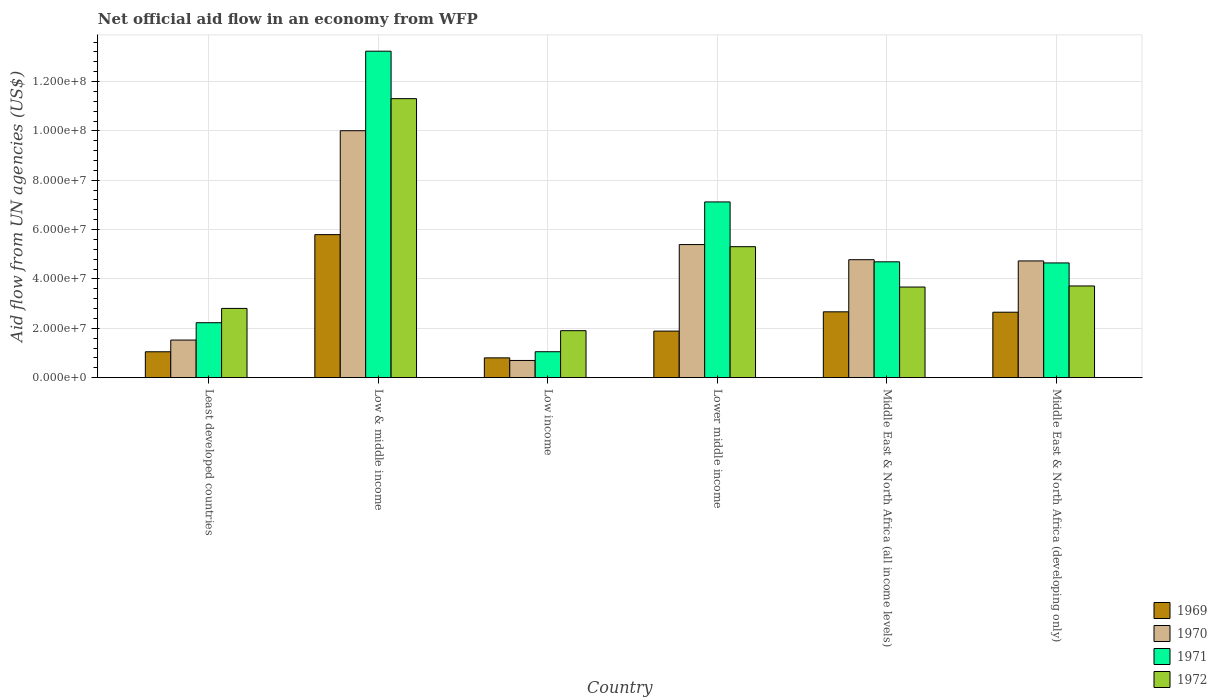How many different coloured bars are there?
Make the answer very short. 4. Are the number of bars on each tick of the X-axis equal?
Your answer should be very brief. Yes. How many bars are there on the 6th tick from the left?
Offer a very short reply. 4. What is the label of the 5th group of bars from the left?
Keep it short and to the point. Middle East & North Africa (all income levels). What is the net official aid flow in 1970 in Least developed countries?
Ensure brevity in your answer.  1.52e+07. Across all countries, what is the maximum net official aid flow in 1970?
Ensure brevity in your answer.  1.00e+08. Across all countries, what is the minimum net official aid flow in 1972?
Provide a short and direct response. 1.90e+07. In which country was the net official aid flow in 1970 maximum?
Offer a terse response. Low & middle income. In which country was the net official aid flow in 1971 minimum?
Your answer should be very brief. Low income. What is the total net official aid flow in 1972 in the graph?
Offer a very short reply. 2.87e+08. What is the difference between the net official aid flow in 1971 in Low income and that in Lower middle income?
Provide a succinct answer. -6.07e+07. What is the difference between the net official aid flow in 1972 in Low & middle income and the net official aid flow in 1971 in Least developed countries?
Offer a very short reply. 9.08e+07. What is the average net official aid flow in 1972 per country?
Offer a very short reply. 4.79e+07. What is the difference between the net official aid flow of/in 1972 and net official aid flow of/in 1970 in Middle East & North Africa (all income levels)?
Give a very brief answer. -1.11e+07. In how many countries, is the net official aid flow in 1971 greater than 60000000 US$?
Your answer should be compact. 2. What is the ratio of the net official aid flow in 1972 in Middle East & North Africa (all income levels) to that in Middle East & North Africa (developing only)?
Ensure brevity in your answer.  0.99. Is the net official aid flow in 1972 in Low & middle income less than that in Middle East & North Africa (all income levels)?
Your answer should be very brief. No. Is the difference between the net official aid flow in 1972 in Low & middle income and Lower middle income greater than the difference between the net official aid flow in 1970 in Low & middle income and Lower middle income?
Offer a very short reply. Yes. What is the difference between the highest and the second highest net official aid flow in 1972?
Make the answer very short. 7.59e+07. What is the difference between the highest and the lowest net official aid flow in 1972?
Offer a terse response. 9.40e+07. Is it the case that in every country, the sum of the net official aid flow in 1971 and net official aid flow in 1969 is greater than the sum of net official aid flow in 1972 and net official aid flow in 1970?
Make the answer very short. No. What does the 1st bar from the left in Lower middle income represents?
Keep it short and to the point. 1969. Is it the case that in every country, the sum of the net official aid flow in 1971 and net official aid flow in 1969 is greater than the net official aid flow in 1970?
Your answer should be compact. Yes. Are all the bars in the graph horizontal?
Keep it short and to the point. No. How many countries are there in the graph?
Keep it short and to the point. 6. What is the difference between two consecutive major ticks on the Y-axis?
Your response must be concise. 2.00e+07. Are the values on the major ticks of Y-axis written in scientific E-notation?
Your answer should be very brief. Yes. Does the graph contain any zero values?
Your response must be concise. No. How many legend labels are there?
Your response must be concise. 4. How are the legend labels stacked?
Offer a terse response. Vertical. What is the title of the graph?
Make the answer very short. Net official aid flow in an economy from WFP. Does "2006" appear as one of the legend labels in the graph?
Your response must be concise. No. What is the label or title of the X-axis?
Provide a succinct answer. Country. What is the label or title of the Y-axis?
Your answer should be very brief. Aid flow from UN agencies (US$). What is the Aid flow from UN agencies (US$) of 1969 in Least developed countries?
Provide a short and direct response. 1.05e+07. What is the Aid flow from UN agencies (US$) of 1970 in Least developed countries?
Your response must be concise. 1.52e+07. What is the Aid flow from UN agencies (US$) of 1971 in Least developed countries?
Keep it short and to the point. 2.23e+07. What is the Aid flow from UN agencies (US$) in 1972 in Least developed countries?
Make the answer very short. 2.81e+07. What is the Aid flow from UN agencies (US$) of 1969 in Low & middle income?
Your answer should be very brief. 5.80e+07. What is the Aid flow from UN agencies (US$) of 1970 in Low & middle income?
Your answer should be compact. 1.00e+08. What is the Aid flow from UN agencies (US$) of 1971 in Low & middle income?
Make the answer very short. 1.32e+08. What is the Aid flow from UN agencies (US$) in 1972 in Low & middle income?
Offer a very short reply. 1.13e+08. What is the Aid flow from UN agencies (US$) in 1969 in Low income?
Offer a terse response. 8.02e+06. What is the Aid flow from UN agencies (US$) of 1970 in Low income?
Ensure brevity in your answer.  6.97e+06. What is the Aid flow from UN agencies (US$) in 1971 in Low income?
Your response must be concise. 1.05e+07. What is the Aid flow from UN agencies (US$) in 1972 in Low income?
Your response must be concise. 1.90e+07. What is the Aid flow from UN agencies (US$) of 1969 in Lower middle income?
Your answer should be compact. 1.89e+07. What is the Aid flow from UN agencies (US$) in 1970 in Lower middle income?
Ensure brevity in your answer.  5.39e+07. What is the Aid flow from UN agencies (US$) of 1971 in Lower middle income?
Keep it short and to the point. 7.12e+07. What is the Aid flow from UN agencies (US$) in 1972 in Lower middle income?
Make the answer very short. 5.31e+07. What is the Aid flow from UN agencies (US$) in 1969 in Middle East & North Africa (all income levels)?
Your response must be concise. 2.67e+07. What is the Aid flow from UN agencies (US$) in 1970 in Middle East & North Africa (all income levels)?
Offer a very short reply. 4.78e+07. What is the Aid flow from UN agencies (US$) in 1971 in Middle East & North Africa (all income levels)?
Give a very brief answer. 4.69e+07. What is the Aid flow from UN agencies (US$) in 1972 in Middle East & North Africa (all income levels)?
Offer a terse response. 3.67e+07. What is the Aid flow from UN agencies (US$) of 1969 in Middle East & North Africa (developing only)?
Provide a succinct answer. 2.65e+07. What is the Aid flow from UN agencies (US$) of 1970 in Middle East & North Africa (developing only)?
Offer a terse response. 4.73e+07. What is the Aid flow from UN agencies (US$) of 1971 in Middle East & North Africa (developing only)?
Give a very brief answer. 4.65e+07. What is the Aid flow from UN agencies (US$) in 1972 in Middle East & North Africa (developing only)?
Your answer should be very brief. 3.72e+07. Across all countries, what is the maximum Aid flow from UN agencies (US$) in 1969?
Make the answer very short. 5.80e+07. Across all countries, what is the maximum Aid flow from UN agencies (US$) in 1970?
Your response must be concise. 1.00e+08. Across all countries, what is the maximum Aid flow from UN agencies (US$) of 1971?
Your answer should be compact. 1.32e+08. Across all countries, what is the maximum Aid flow from UN agencies (US$) in 1972?
Your response must be concise. 1.13e+08. Across all countries, what is the minimum Aid flow from UN agencies (US$) in 1969?
Provide a short and direct response. 8.02e+06. Across all countries, what is the minimum Aid flow from UN agencies (US$) of 1970?
Offer a terse response. 6.97e+06. Across all countries, what is the minimum Aid flow from UN agencies (US$) of 1971?
Give a very brief answer. 1.05e+07. Across all countries, what is the minimum Aid flow from UN agencies (US$) of 1972?
Offer a terse response. 1.90e+07. What is the total Aid flow from UN agencies (US$) in 1969 in the graph?
Provide a short and direct response. 1.49e+08. What is the total Aid flow from UN agencies (US$) of 1970 in the graph?
Provide a short and direct response. 2.71e+08. What is the total Aid flow from UN agencies (US$) of 1971 in the graph?
Give a very brief answer. 3.30e+08. What is the total Aid flow from UN agencies (US$) in 1972 in the graph?
Your answer should be very brief. 2.87e+08. What is the difference between the Aid flow from UN agencies (US$) of 1969 in Least developed countries and that in Low & middle income?
Offer a very short reply. -4.75e+07. What is the difference between the Aid flow from UN agencies (US$) of 1970 in Least developed countries and that in Low & middle income?
Your answer should be compact. -8.48e+07. What is the difference between the Aid flow from UN agencies (US$) in 1971 in Least developed countries and that in Low & middle income?
Make the answer very short. -1.10e+08. What is the difference between the Aid flow from UN agencies (US$) in 1972 in Least developed countries and that in Low & middle income?
Provide a succinct answer. -8.50e+07. What is the difference between the Aid flow from UN agencies (US$) in 1969 in Least developed countries and that in Low income?
Make the answer very short. 2.47e+06. What is the difference between the Aid flow from UN agencies (US$) of 1970 in Least developed countries and that in Low income?
Make the answer very short. 8.27e+06. What is the difference between the Aid flow from UN agencies (US$) of 1971 in Least developed countries and that in Low income?
Offer a terse response. 1.18e+07. What is the difference between the Aid flow from UN agencies (US$) of 1972 in Least developed countries and that in Low income?
Your response must be concise. 9.02e+06. What is the difference between the Aid flow from UN agencies (US$) in 1969 in Least developed countries and that in Lower middle income?
Offer a terse response. -8.38e+06. What is the difference between the Aid flow from UN agencies (US$) of 1970 in Least developed countries and that in Lower middle income?
Provide a succinct answer. -3.87e+07. What is the difference between the Aid flow from UN agencies (US$) in 1971 in Least developed countries and that in Lower middle income?
Your answer should be very brief. -4.89e+07. What is the difference between the Aid flow from UN agencies (US$) of 1972 in Least developed countries and that in Lower middle income?
Provide a short and direct response. -2.50e+07. What is the difference between the Aid flow from UN agencies (US$) in 1969 in Least developed countries and that in Middle East & North Africa (all income levels)?
Keep it short and to the point. -1.62e+07. What is the difference between the Aid flow from UN agencies (US$) of 1970 in Least developed countries and that in Middle East & North Africa (all income levels)?
Give a very brief answer. -3.26e+07. What is the difference between the Aid flow from UN agencies (US$) in 1971 in Least developed countries and that in Middle East & North Africa (all income levels)?
Your response must be concise. -2.47e+07. What is the difference between the Aid flow from UN agencies (US$) in 1972 in Least developed countries and that in Middle East & North Africa (all income levels)?
Give a very brief answer. -8.66e+06. What is the difference between the Aid flow from UN agencies (US$) of 1969 in Least developed countries and that in Middle East & North Africa (developing only)?
Give a very brief answer. -1.60e+07. What is the difference between the Aid flow from UN agencies (US$) of 1970 in Least developed countries and that in Middle East & North Africa (developing only)?
Give a very brief answer. -3.21e+07. What is the difference between the Aid flow from UN agencies (US$) of 1971 in Least developed countries and that in Middle East & North Africa (developing only)?
Your answer should be very brief. -2.42e+07. What is the difference between the Aid flow from UN agencies (US$) of 1972 in Least developed countries and that in Middle East & North Africa (developing only)?
Offer a very short reply. -9.10e+06. What is the difference between the Aid flow from UN agencies (US$) of 1969 in Low & middle income and that in Low income?
Give a very brief answer. 4.99e+07. What is the difference between the Aid flow from UN agencies (US$) in 1970 in Low & middle income and that in Low income?
Your answer should be compact. 9.31e+07. What is the difference between the Aid flow from UN agencies (US$) of 1971 in Low & middle income and that in Low income?
Your answer should be compact. 1.22e+08. What is the difference between the Aid flow from UN agencies (US$) in 1972 in Low & middle income and that in Low income?
Offer a very short reply. 9.40e+07. What is the difference between the Aid flow from UN agencies (US$) of 1969 in Low & middle income and that in Lower middle income?
Ensure brevity in your answer.  3.91e+07. What is the difference between the Aid flow from UN agencies (US$) of 1970 in Low & middle income and that in Lower middle income?
Your answer should be very brief. 4.61e+07. What is the difference between the Aid flow from UN agencies (US$) of 1971 in Low & middle income and that in Lower middle income?
Provide a succinct answer. 6.11e+07. What is the difference between the Aid flow from UN agencies (US$) in 1972 in Low & middle income and that in Lower middle income?
Offer a terse response. 6.00e+07. What is the difference between the Aid flow from UN agencies (US$) of 1969 in Low & middle income and that in Middle East & North Africa (all income levels)?
Ensure brevity in your answer.  3.13e+07. What is the difference between the Aid flow from UN agencies (US$) in 1970 in Low & middle income and that in Middle East & North Africa (all income levels)?
Make the answer very short. 5.23e+07. What is the difference between the Aid flow from UN agencies (US$) in 1971 in Low & middle income and that in Middle East & North Africa (all income levels)?
Make the answer very short. 8.54e+07. What is the difference between the Aid flow from UN agencies (US$) in 1972 in Low & middle income and that in Middle East & North Africa (all income levels)?
Your answer should be compact. 7.63e+07. What is the difference between the Aid flow from UN agencies (US$) of 1969 in Low & middle income and that in Middle East & North Africa (developing only)?
Keep it short and to the point. 3.14e+07. What is the difference between the Aid flow from UN agencies (US$) in 1970 in Low & middle income and that in Middle East & North Africa (developing only)?
Your answer should be compact. 5.28e+07. What is the difference between the Aid flow from UN agencies (US$) of 1971 in Low & middle income and that in Middle East & North Africa (developing only)?
Provide a short and direct response. 8.58e+07. What is the difference between the Aid flow from UN agencies (US$) in 1972 in Low & middle income and that in Middle East & North Africa (developing only)?
Your answer should be compact. 7.59e+07. What is the difference between the Aid flow from UN agencies (US$) of 1969 in Low income and that in Lower middle income?
Offer a terse response. -1.08e+07. What is the difference between the Aid flow from UN agencies (US$) of 1970 in Low income and that in Lower middle income?
Make the answer very short. -4.70e+07. What is the difference between the Aid flow from UN agencies (US$) in 1971 in Low income and that in Lower middle income?
Your answer should be very brief. -6.07e+07. What is the difference between the Aid flow from UN agencies (US$) in 1972 in Low income and that in Lower middle income?
Your answer should be very brief. -3.40e+07. What is the difference between the Aid flow from UN agencies (US$) in 1969 in Low income and that in Middle East & North Africa (all income levels)?
Your response must be concise. -1.87e+07. What is the difference between the Aid flow from UN agencies (US$) in 1970 in Low income and that in Middle East & North Africa (all income levels)?
Your response must be concise. -4.08e+07. What is the difference between the Aid flow from UN agencies (US$) in 1971 in Low income and that in Middle East & North Africa (all income levels)?
Provide a succinct answer. -3.64e+07. What is the difference between the Aid flow from UN agencies (US$) of 1972 in Low income and that in Middle East & North Africa (all income levels)?
Keep it short and to the point. -1.77e+07. What is the difference between the Aid flow from UN agencies (US$) in 1969 in Low income and that in Middle East & North Africa (developing only)?
Provide a short and direct response. -1.85e+07. What is the difference between the Aid flow from UN agencies (US$) in 1970 in Low income and that in Middle East & North Africa (developing only)?
Ensure brevity in your answer.  -4.03e+07. What is the difference between the Aid flow from UN agencies (US$) in 1971 in Low income and that in Middle East & North Africa (developing only)?
Offer a terse response. -3.60e+07. What is the difference between the Aid flow from UN agencies (US$) in 1972 in Low income and that in Middle East & North Africa (developing only)?
Ensure brevity in your answer.  -1.81e+07. What is the difference between the Aid flow from UN agencies (US$) of 1969 in Lower middle income and that in Middle East & North Africa (all income levels)?
Your answer should be very brief. -7.81e+06. What is the difference between the Aid flow from UN agencies (US$) of 1970 in Lower middle income and that in Middle East & North Africa (all income levels)?
Your answer should be compact. 6.13e+06. What is the difference between the Aid flow from UN agencies (US$) of 1971 in Lower middle income and that in Middle East & North Africa (all income levels)?
Keep it short and to the point. 2.43e+07. What is the difference between the Aid flow from UN agencies (US$) in 1972 in Lower middle income and that in Middle East & North Africa (all income levels)?
Provide a succinct answer. 1.64e+07. What is the difference between the Aid flow from UN agencies (US$) of 1969 in Lower middle income and that in Middle East & North Africa (developing only)?
Your answer should be compact. -7.65e+06. What is the difference between the Aid flow from UN agencies (US$) in 1970 in Lower middle income and that in Middle East & North Africa (developing only)?
Keep it short and to the point. 6.63e+06. What is the difference between the Aid flow from UN agencies (US$) of 1971 in Lower middle income and that in Middle East & North Africa (developing only)?
Ensure brevity in your answer.  2.47e+07. What is the difference between the Aid flow from UN agencies (US$) of 1972 in Lower middle income and that in Middle East & North Africa (developing only)?
Provide a succinct answer. 1.59e+07. What is the difference between the Aid flow from UN agencies (US$) of 1972 in Middle East & North Africa (all income levels) and that in Middle East & North Africa (developing only)?
Your answer should be very brief. -4.40e+05. What is the difference between the Aid flow from UN agencies (US$) in 1969 in Least developed countries and the Aid flow from UN agencies (US$) in 1970 in Low & middle income?
Ensure brevity in your answer.  -8.96e+07. What is the difference between the Aid flow from UN agencies (US$) in 1969 in Least developed countries and the Aid flow from UN agencies (US$) in 1971 in Low & middle income?
Your answer should be compact. -1.22e+08. What is the difference between the Aid flow from UN agencies (US$) in 1969 in Least developed countries and the Aid flow from UN agencies (US$) in 1972 in Low & middle income?
Give a very brief answer. -1.03e+08. What is the difference between the Aid flow from UN agencies (US$) in 1970 in Least developed countries and the Aid flow from UN agencies (US$) in 1971 in Low & middle income?
Offer a terse response. -1.17e+08. What is the difference between the Aid flow from UN agencies (US$) of 1970 in Least developed countries and the Aid flow from UN agencies (US$) of 1972 in Low & middle income?
Give a very brief answer. -9.78e+07. What is the difference between the Aid flow from UN agencies (US$) in 1971 in Least developed countries and the Aid flow from UN agencies (US$) in 1972 in Low & middle income?
Offer a terse response. -9.08e+07. What is the difference between the Aid flow from UN agencies (US$) in 1969 in Least developed countries and the Aid flow from UN agencies (US$) in 1970 in Low income?
Make the answer very short. 3.52e+06. What is the difference between the Aid flow from UN agencies (US$) of 1969 in Least developed countries and the Aid flow from UN agencies (US$) of 1972 in Low income?
Your response must be concise. -8.55e+06. What is the difference between the Aid flow from UN agencies (US$) in 1970 in Least developed countries and the Aid flow from UN agencies (US$) in 1971 in Low income?
Offer a very short reply. 4.73e+06. What is the difference between the Aid flow from UN agencies (US$) in 1970 in Least developed countries and the Aid flow from UN agencies (US$) in 1972 in Low income?
Make the answer very short. -3.80e+06. What is the difference between the Aid flow from UN agencies (US$) of 1971 in Least developed countries and the Aid flow from UN agencies (US$) of 1972 in Low income?
Your answer should be very brief. 3.23e+06. What is the difference between the Aid flow from UN agencies (US$) in 1969 in Least developed countries and the Aid flow from UN agencies (US$) in 1970 in Lower middle income?
Provide a short and direct response. -4.34e+07. What is the difference between the Aid flow from UN agencies (US$) of 1969 in Least developed countries and the Aid flow from UN agencies (US$) of 1971 in Lower middle income?
Offer a terse response. -6.07e+07. What is the difference between the Aid flow from UN agencies (US$) of 1969 in Least developed countries and the Aid flow from UN agencies (US$) of 1972 in Lower middle income?
Provide a succinct answer. -4.26e+07. What is the difference between the Aid flow from UN agencies (US$) in 1970 in Least developed countries and the Aid flow from UN agencies (US$) in 1971 in Lower middle income?
Your response must be concise. -5.60e+07. What is the difference between the Aid flow from UN agencies (US$) in 1970 in Least developed countries and the Aid flow from UN agencies (US$) in 1972 in Lower middle income?
Keep it short and to the point. -3.78e+07. What is the difference between the Aid flow from UN agencies (US$) in 1971 in Least developed countries and the Aid flow from UN agencies (US$) in 1972 in Lower middle income?
Your response must be concise. -3.08e+07. What is the difference between the Aid flow from UN agencies (US$) of 1969 in Least developed countries and the Aid flow from UN agencies (US$) of 1970 in Middle East & North Africa (all income levels)?
Keep it short and to the point. -3.73e+07. What is the difference between the Aid flow from UN agencies (US$) of 1969 in Least developed countries and the Aid flow from UN agencies (US$) of 1971 in Middle East & North Africa (all income levels)?
Make the answer very short. -3.64e+07. What is the difference between the Aid flow from UN agencies (US$) in 1969 in Least developed countries and the Aid flow from UN agencies (US$) in 1972 in Middle East & North Africa (all income levels)?
Your answer should be very brief. -2.62e+07. What is the difference between the Aid flow from UN agencies (US$) in 1970 in Least developed countries and the Aid flow from UN agencies (US$) in 1971 in Middle East & North Africa (all income levels)?
Offer a terse response. -3.17e+07. What is the difference between the Aid flow from UN agencies (US$) in 1970 in Least developed countries and the Aid flow from UN agencies (US$) in 1972 in Middle East & North Africa (all income levels)?
Give a very brief answer. -2.15e+07. What is the difference between the Aid flow from UN agencies (US$) in 1971 in Least developed countries and the Aid flow from UN agencies (US$) in 1972 in Middle East & North Africa (all income levels)?
Your response must be concise. -1.44e+07. What is the difference between the Aid flow from UN agencies (US$) in 1969 in Least developed countries and the Aid flow from UN agencies (US$) in 1970 in Middle East & North Africa (developing only)?
Offer a terse response. -3.68e+07. What is the difference between the Aid flow from UN agencies (US$) in 1969 in Least developed countries and the Aid flow from UN agencies (US$) in 1971 in Middle East & North Africa (developing only)?
Offer a very short reply. -3.60e+07. What is the difference between the Aid flow from UN agencies (US$) of 1969 in Least developed countries and the Aid flow from UN agencies (US$) of 1972 in Middle East & North Africa (developing only)?
Offer a very short reply. -2.67e+07. What is the difference between the Aid flow from UN agencies (US$) of 1970 in Least developed countries and the Aid flow from UN agencies (US$) of 1971 in Middle East & North Africa (developing only)?
Keep it short and to the point. -3.12e+07. What is the difference between the Aid flow from UN agencies (US$) of 1970 in Least developed countries and the Aid flow from UN agencies (US$) of 1972 in Middle East & North Africa (developing only)?
Offer a terse response. -2.19e+07. What is the difference between the Aid flow from UN agencies (US$) of 1971 in Least developed countries and the Aid flow from UN agencies (US$) of 1972 in Middle East & North Africa (developing only)?
Provide a short and direct response. -1.49e+07. What is the difference between the Aid flow from UN agencies (US$) in 1969 in Low & middle income and the Aid flow from UN agencies (US$) in 1970 in Low income?
Provide a succinct answer. 5.10e+07. What is the difference between the Aid flow from UN agencies (US$) of 1969 in Low & middle income and the Aid flow from UN agencies (US$) of 1971 in Low income?
Provide a short and direct response. 4.74e+07. What is the difference between the Aid flow from UN agencies (US$) of 1969 in Low & middle income and the Aid flow from UN agencies (US$) of 1972 in Low income?
Offer a terse response. 3.89e+07. What is the difference between the Aid flow from UN agencies (US$) in 1970 in Low & middle income and the Aid flow from UN agencies (US$) in 1971 in Low income?
Your response must be concise. 8.96e+07. What is the difference between the Aid flow from UN agencies (US$) of 1970 in Low & middle income and the Aid flow from UN agencies (US$) of 1972 in Low income?
Provide a short and direct response. 8.10e+07. What is the difference between the Aid flow from UN agencies (US$) of 1971 in Low & middle income and the Aid flow from UN agencies (US$) of 1972 in Low income?
Offer a terse response. 1.13e+08. What is the difference between the Aid flow from UN agencies (US$) of 1969 in Low & middle income and the Aid flow from UN agencies (US$) of 1970 in Lower middle income?
Offer a very short reply. 4.03e+06. What is the difference between the Aid flow from UN agencies (US$) in 1969 in Low & middle income and the Aid flow from UN agencies (US$) in 1971 in Lower middle income?
Give a very brief answer. -1.32e+07. What is the difference between the Aid flow from UN agencies (US$) in 1969 in Low & middle income and the Aid flow from UN agencies (US$) in 1972 in Lower middle income?
Offer a very short reply. 4.88e+06. What is the difference between the Aid flow from UN agencies (US$) of 1970 in Low & middle income and the Aid flow from UN agencies (US$) of 1971 in Lower middle income?
Give a very brief answer. 2.89e+07. What is the difference between the Aid flow from UN agencies (US$) in 1970 in Low & middle income and the Aid flow from UN agencies (US$) in 1972 in Lower middle income?
Your answer should be very brief. 4.70e+07. What is the difference between the Aid flow from UN agencies (US$) in 1971 in Low & middle income and the Aid flow from UN agencies (US$) in 1972 in Lower middle income?
Provide a succinct answer. 7.92e+07. What is the difference between the Aid flow from UN agencies (US$) of 1969 in Low & middle income and the Aid flow from UN agencies (US$) of 1970 in Middle East & North Africa (all income levels)?
Offer a very short reply. 1.02e+07. What is the difference between the Aid flow from UN agencies (US$) of 1969 in Low & middle income and the Aid flow from UN agencies (US$) of 1971 in Middle East & North Africa (all income levels)?
Provide a short and direct response. 1.10e+07. What is the difference between the Aid flow from UN agencies (US$) in 1969 in Low & middle income and the Aid flow from UN agencies (US$) in 1972 in Middle East & North Africa (all income levels)?
Offer a very short reply. 2.12e+07. What is the difference between the Aid flow from UN agencies (US$) of 1970 in Low & middle income and the Aid flow from UN agencies (US$) of 1971 in Middle East & North Africa (all income levels)?
Provide a succinct answer. 5.31e+07. What is the difference between the Aid flow from UN agencies (US$) in 1970 in Low & middle income and the Aid flow from UN agencies (US$) in 1972 in Middle East & North Africa (all income levels)?
Your response must be concise. 6.34e+07. What is the difference between the Aid flow from UN agencies (US$) of 1971 in Low & middle income and the Aid flow from UN agencies (US$) of 1972 in Middle East & North Africa (all income levels)?
Ensure brevity in your answer.  9.56e+07. What is the difference between the Aid flow from UN agencies (US$) in 1969 in Low & middle income and the Aid flow from UN agencies (US$) in 1970 in Middle East & North Africa (developing only)?
Make the answer very short. 1.07e+07. What is the difference between the Aid flow from UN agencies (US$) in 1969 in Low & middle income and the Aid flow from UN agencies (US$) in 1971 in Middle East & North Africa (developing only)?
Provide a short and direct response. 1.15e+07. What is the difference between the Aid flow from UN agencies (US$) of 1969 in Low & middle income and the Aid flow from UN agencies (US$) of 1972 in Middle East & North Africa (developing only)?
Offer a very short reply. 2.08e+07. What is the difference between the Aid flow from UN agencies (US$) of 1970 in Low & middle income and the Aid flow from UN agencies (US$) of 1971 in Middle East & North Africa (developing only)?
Offer a terse response. 5.36e+07. What is the difference between the Aid flow from UN agencies (US$) of 1970 in Low & middle income and the Aid flow from UN agencies (US$) of 1972 in Middle East & North Africa (developing only)?
Give a very brief answer. 6.29e+07. What is the difference between the Aid flow from UN agencies (US$) of 1971 in Low & middle income and the Aid flow from UN agencies (US$) of 1972 in Middle East & North Africa (developing only)?
Your answer should be compact. 9.51e+07. What is the difference between the Aid flow from UN agencies (US$) of 1969 in Low income and the Aid flow from UN agencies (US$) of 1970 in Lower middle income?
Offer a terse response. -4.59e+07. What is the difference between the Aid flow from UN agencies (US$) in 1969 in Low income and the Aid flow from UN agencies (US$) in 1971 in Lower middle income?
Ensure brevity in your answer.  -6.32e+07. What is the difference between the Aid flow from UN agencies (US$) in 1969 in Low income and the Aid flow from UN agencies (US$) in 1972 in Lower middle income?
Offer a terse response. -4.51e+07. What is the difference between the Aid flow from UN agencies (US$) of 1970 in Low income and the Aid flow from UN agencies (US$) of 1971 in Lower middle income?
Offer a terse response. -6.42e+07. What is the difference between the Aid flow from UN agencies (US$) in 1970 in Low income and the Aid flow from UN agencies (US$) in 1972 in Lower middle income?
Your answer should be compact. -4.61e+07. What is the difference between the Aid flow from UN agencies (US$) in 1971 in Low income and the Aid flow from UN agencies (US$) in 1972 in Lower middle income?
Make the answer very short. -4.26e+07. What is the difference between the Aid flow from UN agencies (US$) of 1969 in Low income and the Aid flow from UN agencies (US$) of 1970 in Middle East & North Africa (all income levels)?
Offer a very short reply. -3.98e+07. What is the difference between the Aid flow from UN agencies (US$) in 1969 in Low income and the Aid flow from UN agencies (US$) in 1971 in Middle East & North Africa (all income levels)?
Offer a very short reply. -3.89e+07. What is the difference between the Aid flow from UN agencies (US$) of 1969 in Low income and the Aid flow from UN agencies (US$) of 1972 in Middle East & North Africa (all income levels)?
Keep it short and to the point. -2.87e+07. What is the difference between the Aid flow from UN agencies (US$) in 1970 in Low income and the Aid flow from UN agencies (US$) in 1971 in Middle East & North Africa (all income levels)?
Offer a very short reply. -4.00e+07. What is the difference between the Aid flow from UN agencies (US$) of 1970 in Low income and the Aid flow from UN agencies (US$) of 1972 in Middle East & North Africa (all income levels)?
Give a very brief answer. -2.98e+07. What is the difference between the Aid flow from UN agencies (US$) of 1971 in Low income and the Aid flow from UN agencies (US$) of 1972 in Middle East & North Africa (all income levels)?
Give a very brief answer. -2.62e+07. What is the difference between the Aid flow from UN agencies (US$) in 1969 in Low income and the Aid flow from UN agencies (US$) in 1970 in Middle East & North Africa (developing only)?
Provide a short and direct response. -3.93e+07. What is the difference between the Aid flow from UN agencies (US$) of 1969 in Low income and the Aid flow from UN agencies (US$) of 1971 in Middle East & North Africa (developing only)?
Provide a short and direct response. -3.85e+07. What is the difference between the Aid flow from UN agencies (US$) of 1969 in Low income and the Aid flow from UN agencies (US$) of 1972 in Middle East & North Africa (developing only)?
Offer a very short reply. -2.91e+07. What is the difference between the Aid flow from UN agencies (US$) in 1970 in Low income and the Aid flow from UN agencies (US$) in 1971 in Middle East & North Africa (developing only)?
Your answer should be very brief. -3.95e+07. What is the difference between the Aid flow from UN agencies (US$) of 1970 in Low income and the Aid flow from UN agencies (US$) of 1972 in Middle East & North Africa (developing only)?
Provide a short and direct response. -3.02e+07. What is the difference between the Aid flow from UN agencies (US$) of 1971 in Low income and the Aid flow from UN agencies (US$) of 1972 in Middle East & North Africa (developing only)?
Ensure brevity in your answer.  -2.66e+07. What is the difference between the Aid flow from UN agencies (US$) of 1969 in Lower middle income and the Aid flow from UN agencies (US$) of 1970 in Middle East & North Africa (all income levels)?
Provide a succinct answer. -2.89e+07. What is the difference between the Aid flow from UN agencies (US$) of 1969 in Lower middle income and the Aid flow from UN agencies (US$) of 1971 in Middle East & North Africa (all income levels)?
Provide a short and direct response. -2.81e+07. What is the difference between the Aid flow from UN agencies (US$) in 1969 in Lower middle income and the Aid flow from UN agencies (US$) in 1972 in Middle East & North Africa (all income levels)?
Offer a very short reply. -1.78e+07. What is the difference between the Aid flow from UN agencies (US$) of 1970 in Lower middle income and the Aid flow from UN agencies (US$) of 1971 in Middle East & North Africa (all income levels)?
Ensure brevity in your answer.  6.99e+06. What is the difference between the Aid flow from UN agencies (US$) in 1970 in Lower middle income and the Aid flow from UN agencies (US$) in 1972 in Middle East & North Africa (all income levels)?
Provide a succinct answer. 1.72e+07. What is the difference between the Aid flow from UN agencies (US$) in 1971 in Lower middle income and the Aid flow from UN agencies (US$) in 1972 in Middle East & North Africa (all income levels)?
Your response must be concise. 3.45e+07. What is the difference between the Aid flow from UN agencies (US$) of 1969 in Lower middle income and the Aid flow from UN agencies (US$) of 1970 in Middle East & North Africa (developing only)?
Your answer should be compact. -2.84e+07. What is the difference between the Aid flow from UN agencies (US$) in 1969 in Lower middle income and the Aid flow from UN agencies (US$) in 1971 in Middle East & North Africa (developing only)?
Make the answer very short. -2.76e+07. What is the difference between the Aid flow from UN agencies (US$) in 1969 in Lower middle income and the Aid flow from UN agencies (US$) in 1972 in Middle East & North Africa (developing only)?
Provide a short and direct response. -1.83e+07. What is the difference between the Aid flow from UN agencies (US$) in 1970 in Lower middle income and the Aid flow from UN agencies (US$) in 1971 in Middle East & North Africa (developing only)?
Provide a succinct answer. 7.44e+06. What is the difference between the Aid flow from UN agencies (US$) in 1970 in Lower middle income and the Aid flow from UN agencies (US$) in 1972 in Middle East & North Africa (developing only)?
Offer a very short reply. 1.68e+07. What is the difference between the Aid flow from UN agencies (US$) of 1971 in Lower middle income and the Aid flow from UN agencies (US$) of 1972 in Middle East & North Africa (developing only)?
Offer a terse response. 3.40e+07. What is the difference between the Aid flow from UN agencies (US$) of 1969 in Middle East & North Africa (all income levels) and the Aid flow from UN agencies (US$) of 1970 in Middle East & North Africa (developing only)?
Provide a short and direct response. -2.06e+07. What is the difference between the Aid flow from UN agencies (US$) in 1969 in Middle East & North Africa (all income levels) and the Aid flow from UN agencies (US$) in 1971 in Middle East & North Africa (developing only)?
Your answer should be very brief. -1.98e+07. What is the difference between the Aid flow from UN agencies (US$) in 1969 in Middle East & North Africa (all income levels) and the Aid flow from UN agencies (US$) in 1972 in Middle East & North Africa (developing only)?
Ensure brevity in your answer.  -1.05e+07. What is the difference between the Aid flow from UN agencies (US$) of 1970 in Middle East & North Africa (all income levels) and the Aid flow from UN agencies (US$) of 1971 in Middle East & North Africa (developing only)?
Make the answer very short. 1.31e+06. What is the difference between the Aid flow from UN agencies (US$) of 1970 in Middle East & North Africa (all income levels) and the Aid flow from UN agencies (US$) of 1972 in Middle East & North Africa (developing only)?
Keep it short and to the point. 1.06e+07. What is the difference between the Aid flow from UN agencies (US$) of 1971 in Middle East & North Africa (all income levels) and the Aid flow from UN agencies (US$) of 1972 in Middle East & North Africa (developing only)?
Offer a very short reply. 9.78e+06. What is the average Aid flow from UN agencies (US$) of 1969 per country?
Give a very brief answer. 2.48e+07. What is the average Aid flow from UN agencies (US$) of 1970 per country?
Your answer should be very brief. 4.52e+07. What is the average Aid flow from UN agencies (US$) of 1971 per country?
Give a very brief answer. 5.50e+07. What is the average Aid flow from UN agencies (US$) of 1972 per country?
Ensure brevity in your answer.  4.79e+07. What is the difference between the Aid flow from UN agencies (US$) in 1969 and Aid flow from UN agencies (US$) in 1970 in Least developed countries?
Your answer should be compact. -4.75e+06. What is the difference between the Aid flow from UN agencies (US$) of 1969 and Aid flow from UN agencies (US$) of 1971 in Least developed countries?
Your answer should be compact. -1.18e+07. What is the difference between the Aid flow from UN agencies (US$) of 1969 and Aid flow from UN agencies (US$) of 1972 in Least developed countries?
Provide a succinct answer. -1.76e+07. What is the difference between the Aid flow from UN agencies (US$) in 1970 and Aid flow from UN agencies (US$) in 1971 in Least developed countries?
Your answer should be very brief. -7.03e+06. What is the difference between the Aid flow from UN agencies (US$) in 1970 and Aid flow from UN agencies (US$) in 1972 in Least developed countries?
Provide a succinct answer. -1.28e+07. What is the difference between the Aid flow from UN agencies (US$) in 1971 and Aid flow from UN agencies (US$) in 1972 in Least developed countries?
Your answer should be compact. -5.79e+06. What is the difference between the Aid flow from UN agencies (US$) in 1969 and Aid flow from UN agencies (US$) in 1970 in Low & middle income?
Your answer should be compact. -4.21e+07. What is the difference between the Aid flow from UN agencies (US$) of 1969 and Aid flow from UN agencies (US$) of 1971 in Low & middle income?
Ensure brevity in your answer.  -7.43e+07. What is the difference between the Aid flow from UN agencies (US$) of 1969 and Aid flow from UN agencies (US$) of 1972 in Low & middle income?
Offer a very short reply. -5.51e+07. What is the difference between the Aid flow from UN agencies (US$) in 1970 and Aid flow from UN agencies (US$) in 1971 in Low & middle income?
Provide a succinct answer. -3.22e+07. What is the difference between the Aid flow from UN agencies (US$) of 1970 and Aid flow from UN agencies (US$) of 1972 in Low & middle income?
Offer a terse response. -1.30e+07. What is the difference between the Aid flow from UN agencies (US$) of 1971 and Aid flow from UN agencies (US$) of 1972 in Low & middle income?
Offer a terse response. 1.92e+07. What is the difference between the Aid flow from UN agencies (US$) of 1969 and Aid flow from UN agencies (US$) of 1970 in Low income?
Your answer should be compact. 1.05e+06. What is the difference between the Aid flow from UN agencies (US$) of 1969 and Aid flow from UN agencies (US$) of 1971 in Low income?
Your response must be concise. -2.49e+06. What is the difference between the Aid flow from UN agencies (US$) of 1969 and Aid flow from UN agencies (US$) of 1972 in Low income?
Your answer should be compact. -1.10e+07. What is the difference between the Aid flow from UN agencies (US$) of 1970 and Aid flow from UN agencies (US$) of 1971 in Low income?
Keep it short and to the point. -3.54e+06. What is the difference between the Aid flow from UN agencies (US$) in 1970 and Aid flow from UN agencies (US$) in 1972 in Low income?
Provide a short and direct response. -1.21e+07. What is the difference between the Aid flow from UN agencies (US$) in 1971 and Aid flow from UN agencies (US$) in 1972 in Low income?
Your response must be concise. -8.53e+06. What is the difference between the Aid flow from UN agencies (US$) in 1969 and Aid flow from UN agencies (US$) in 1970 in Lower middle income?
Ensure brevity in your answer.  -3.51e+07. What is the difference between the Aid flow from UN agencies (US$) in 1969 and Aid flow from UN agencies (US$) in 1971 in Lower middle income?
Your response must be concise. -5.23e+07. What is the difference between the Aid flow from UN agencies (US$) of 1969 and Aid flow from UN agencies (US$) of 1972 in Lower middle income?
Give a very brief answer. -3.42e+07. What is the difference between the Aid flow from UN agencies (US$) in 1970 and Aid flow from UN agencies (US$) in 1971 in Lower middle income?
Ensure brevity in your answer.  -1.73e+07. What is the difference between the Aid flow from UN agencies (US$) of 1970 and Aid flow from UN agencies (US$) of 1972 in Lower middle income?
Your answer should be compact. 8.50e+05. What is the difference between the Aid flow from UN agencies (US$) of 1971 and Aid flow from UN agencies (US$) of 1972 in Lower middle income?
Offer a very short reply. 1.81e+07. What is the difference between the Aid flow from UN agencies (US$) of 1969 and Aid flow from UN agencies (US$) of 1970 in Middle East & North Africa (all income levels)?
Make the answer very short. -2.11e+07. What is the difference between the Aid flow from UN agencies (US$) of 1969 and Aid flow from UN agencies (US$) of 1971 in Middle East & North Africa (all income levels)?
Provide a succinct answer. -2.03e+07. What is the difference between the Aid flow from UN agencies (US$) of 1969 and Aid flow from UN agencies (US$) of 1972 in Middle East & North Africa (all income levels)?
Make the answer very short. -1.00e+07. What is the difference between the Aid flow from UN agencies (US$) in 1970 and Aid flow from UN agencies (US$) in 1971 in Middle East & North Africa (all income levels)?
Your answer should be very brief. 8.60e+05. What is the difference between the Aid flow from UN agencies (US$) of 1970 and Aid flow from UN agencies (US$) of 1972 in Middle East & North Africa (all income levels)?
Your response must be concise. 1.11e+07. What is the difference between the Aid flow from UN agencies (US$) of 1971 and Aid flow from UN agencies (US$) of 1972 in Middle East & North Africa (all income levels)?
Make the answer very short. 1.02e+07. What is the difference between the Aid flow from UN agencies (US$) of 1969 and Aid flow from UN agencies (US$) of 1970 in Middle East & North Africa (developing only)?
Make the answer very short. -2.08e+07. What is the difference between the Aid flow from UN agencies (US$) of 1969 and Aid flow from UN agencies (US$) of 1971 in Middle East & North Africa (developing only)?
Provide a short and direct response. -2.00e+07. What is the difference between the Aid flow from UN agencies (US$) of 1969 and Aid flow from UN agencies (US$) of 1972 in Middle East & North Africa (developing only)?
Offer a terse response. -1.06e+07. What is the difference between the Aid flow from UN agencies (US$) of 1970 and Aid flow from UN agencies (US$) of 1971 in Middle East & North Africa (developing only)?
Ensure brevity in your answer.  8.10e+05. What is the difference between the Aid flow from UN agencies (US$) in 1970 and Aid flow from UN agencies (US$) in 1972 in Middle East & North Africa (developing only)?
Provide a short and direct response. 1.01e+07. What is the difference between the Aid flow from UN agencies (US$) in 1971 and Aid flow from UN agencies (US$) in 1972 in Middle East & North Africa (developing only)?
Make the answer very short. 9.33e+06. What is the ratio of the Aid flow from UN agencies (US$) of 1969 in Least developed countries to that in Low & middle income?
Provide a succinct answer. 0.18. What is the ratio of the Aid flow from UN agencies (US$) in 1970 in Least developed countries to that in Low & middle income?
Offer a terse response. 0.15. What is the ratio of the Aid flow from UN agencies (US$) in 1971 in Least developed countries to that in Low & middle income?
Provide a succinct answer. 0.17. What is the ratio of the Aid flow from UN agencies (US$) of 1972 in Least developed countries to that in Low & middle income?
Offer a terse response. 0.25. What is the ratio of the Aid flow from UN agencies (US$) in 1969 in Least developed countries to that in Low income?
Your answer should be compact. 1.31. What is the ratio of the Aid flow from UN agencies (US$) of 1970 in Least developed countries to that in Low income?
Your answer should be very brief. 2.19. What is the ratio of the Aid flow from UN agencies (US$) of 1971 in Least developed countries to that in Low income?
Offer a terse response. 2.12. What is the ratio of the Aid flow from UN agencies (US$) of 1972 in Least developed countries to that in Low income?
Make the answer very short. 1.47. What is the ratio of the Aid flow from UN agencies (US$) in 1969 in Least developed countries to that in Lower middle income?
Offer a very short reply. 0.56. What is the ratio of the Aid flow from UN agencies (US$) in 1970 in Least developed countries to that in Lower middle income?
Your answer should be compact. 0.28. What is the ratio of the Aid flow from UN agencies (US$) of 1971 in Least developed countries to that in Lower middle income?
Your response must be concise. 0.31. What is the ratio of the Aid flow from UN agencies (US$) of 1972 in Least developed countries to that in Lower middle income?
Provide a succinct answer. 0.53. What is the ratio of the Aid flow from UN agencies (US$) of 1969 in Least developed countries to that in Middle East & North Africa (all income levels)?
Keep it short and to the point. 0.39. What is the ratio of the Aid flow from UN agencies (US$) in 1970 in Least developed countries to that in Middle East & North Africa (all income levels)?
Your response must be concise. 0.32. What is the ratio of the Aid flow from UN agencies (US$) of 1971 in Least developed countries to that in Middle East & North Africa (all income levels)?
Provide a succinct answer. 0.47. What is the ratio of the Aid flow from UN agencies (US$) of 1972 in Least developed countries to that in Middle East & North Africa (all income levels)?
Offer a very short reply. 0.76. What is the ratio of the Aid flow from UN agencies (US$) of 1969 in Least developed countries to that in Middle East & North Africa (developing only)?
Provide a short and direct response. 0.4. What is the ratio of the Aid flow from UN agencies (US$) in 1970 in Least developed countries to that in Middle East & North Africa (developing only)?
Your answer should be very brief. 0.32. What is the ratio of the Aid flow from UN agencies (US$) of 1971 in Least developed countries to that in Middle East & North Africa (developing only)?
Make the answer very short. 0.48. What is the ratio of the Aid flow from UN agencies (US$) in 1972 in Least developed countries to that in Middle East & North Africa (developing only)?
Keep it short and to the point. 0.76. What is the ratio of the Aid flow from UN agencies (US$) in 1969 in Low & middle income to that in Low income?
Ensure brevity in your answer.  7.23. What is the ratio of the Aid flow from UN agencies (US$) of 1970 in Low & middle income to that in Low income?
Offer a very short reply. 14.36. What is the ratio of the Aid flow from UN agencies (US$) in 1971 in Low & middle income to that in Low income?
Your answer should be compact. 12.59. What is the ratio of the Aid flow from UN agencies (US$) of 1972 in Low & middle income to that in Low income?
Offer a very short reply. 5.94. What is the ratio of the Aid flow from UN agencies (US$) of 1969 in Low & middle income to that in Lower middle income?
Ensure brevity in your answer.  3.07. What is the ratio of the Aid flow from UN agencies (US$) of 1970 in Low & middle income to that in Lower middle income?
Ensure brevity in your answer.  1.86. What is the ratio of the Aid flow from UN agencies (US$) in 1971 in Low & middle income to that in Lower middle income?
Keep it short and to the point. 1.86. What is the ratio of the Aid flow from UN agencies (US$) in 1972 in Low & middle income to that in Lower middle income?
Your response must be concise. 2.13. What is the ratio of the Aid flow from UN agencies (US$) of 1969 in Low & middle income to that in Middle East & North Africa (all income levels)?
Make the answer very short. 2.17. What is the ratio of the Aid flow from UN agencies (US$) in 1970 in Low & middle income to that in Middle East & North Africa (all income levels)?
Provide a succinct answer. 2.09. What is the ratio of the Aid flow from UN agencies (US$) of 1971 in Low & middle income to that in Middle East & North Africa (all income levels)?
Your answer should be very brief. 2.82. What is the ratio of the Aid flow from UN agencies (US$) of 1972 in Low & middle income to that in Middle East & North Africa (all income levels)?
Give a very brief answer. 3.08. What is the ratio of the Aid flow from UN agencies (US$) of 1969 in Low & middle income to that in Middle East & North Africa (developing only)?
Your answer should be compact. 2.19. What is the ratio of the Aid flow from UN agencies (US$) in 1970 in Low & middle income to that in Middle East & North Africa (developing only)?
Your answer should be compact. 2.12. What is the ratio of the Aid flow from UN agencies (US$) in 1971 in Low & middle income to that in Middle East & North Africa (developing only)?
Keep it short and to the point. 2.85. What is the ratio of the Aid flow from UN agencies (US$) of 1972 in Low & middle income to that in Middle East & North Africa (developing only)?
Offer a terse response. 3.04. What is the ratio of the Aid flow from UN agencies (US$) of 1969 in Low income to that in Lower middle income?
Provide a short and direct response. 0.42. What is the ratio of the Aid flow from UN agencies (US$) in 1970 in Low income to that in Lower middle income?
Your response must be concise. 0.13. What is the ratio of the Aid flow from UN agencies (US$) in 1971 in Low income to that in Lower middle income?
Make the answer very short. 0.15. What is the ratio of the Aid flow from UN agencies (US$) in 1972 in Low income to that in Lower middle income?
Keep it short and to the point. 0.36. What is the ratio of the Aid flow from UN agencies (US$) of 1969 in Low income to that in Middle East & North Africa (all income levels)?
Your answer should be compact. 0.3. What is the ratio of the Aid flow from UN agencies (US$) in 1970 in Low income to that in Middle East & North Africa (all income levels)?
Your answer should be compact. 0.15. What is the ratio of the Aid flow from UN agencies (US$) of 1971 in Low income to that in Middle East & North Africa (all income levels)?
Offer a very short reply. 0.22. What is the ratio of the Aid flow from UN agencies (US$) of 1972 in Low income to that in Middle East & North Africa (all income levels)?
Give a very brief answer. 0.52. What is the ratio of the Aid flow from UN agencies (US$) in 1969 in Low income to that in Middle East & North Africa (developing only)?
Keep it short and to the point. 0.3. What is the ratio of the Aid flow from UN agencies (US$) in 1970 in Low income to that in Middle East & North Africa (developing only)?
Your answer should be very brief. 0.15. What is the ratio of the Aid flow from UN agencies (US$) of 1971 in Low income to that in Middle East & North Africa (developing only)?
Make the answer very short. 0.23. What is the ratio of the Aid flow from UN agencies (US$) in 1972 in Low income to that in Middle East & North Africa (developing only)?
Give a very brief answer. 0.51. What is the ratio of the Aid flow from UN agencies (US$) in 1969 in Lower middle income to that in Middle East & North Africa (all income levels)?
Your response must be concise. 0.71. What is the ratio of the Aid flow from UN agencies (US$) of 1970 in Lower middle income to that in Middle East & North Africa (all income levels)?
Offer a terse response. 1.13. What is the ratio of the Aid flow from UN agencies (US$) of 1971 in Lower middle income to that in Middle East & North Africa (all income levels)?
Your answer should be very brief. 1.52. What is the ratio of the Aid flow from UN agencies (US$) in 1972 in Lower middle income to that in Middle East & North Africa (all income levels)?
Offer a terse response. 1.45. What is the ratio of the Aid flow from UN agencies (US$) in 1969 in Lower middle income to that in Middle East & North Africa (developing only)?
Keep it short and to the point. 0.71. What is the ratio of the Aid flow from UN agencies (US$) of 1970 in Lower middle income to that in Middle East & North Africa (developing only)?
Your answer should be very brief. 1.14. What is the ratio of the Aid flow from UN agencies (US$) in 1971 in Lower middle income to that in Middle East & North Africa (developing only)?
Offer a terse response. 1.53. What is the ratio of the Aid flow from UN agencies (US$) of 1972 in Lower middle income to that in Middle East & North Africa (developing only)?
Offer a terse response. 1.43. What is the ratio of the Aid flow from UN agencies (US$) of 1969 in Middle East & North Africa (all income levels) to that in Middle East & North Africa (developing only)?
Your response must be concise. 1.01. What is the ratio of the Aid flow from UN agencies (US$) of 1970 in Middle East & North Africa (all income levels) to that in Middle East & North Africa (developing only)?
Ensure brevity in your answer.  1.01. What is the ratio of the Aid flow from UN agencies (US$) in 1971 in Middle East & North Africa (all income levels) to that in Middle East & North Africa (developing only)?
Your answer should be very brief. 1.01. What is the ratio of the Aid flow from UN agencies (US$) of 1972 in Middle East & North Africa (all income levels) to that in Middle East & North Africa (developing only)?
Ensure brevity in your answer.  0.99. What is the difference between the highest and the second highest Aid flow from UN agencies (US$) of 1969?
Offer a terse response. 3.13e+07. What is the difference between the highest and the second highest Aid flow from UN agencies (US$) in 1970?
Make the answer very short. 4.61e+07. What is the difference between the highest and the second highest Aid flow from UN agencies (US$) of 1971?
Offer a terse response. 6.11e+07. What is the difference between the highest and the second highest Aid flow from UN agencies (US$) in 1972?
Offer a very short reply. 6.00e+07. What is the difference between the highest and the lowest Aid flow from UN agencies (US$) of 1969?
Make the answer very short. 4.99e+07. What is the difference between the highest and the lowest Aid flow from UN agencies (US$) of 1970?
Provide a succinct answer. 9.31e+07. What is the difference between the highest and the lowest Aid flow from UN agencies (US$) of 1971?
Provide a succinct answer. 1.22e+08. What is the difference between the highest and the lowest Aid flow from UN agencies (US$) in 1972?
Your answer should be compact. 9.40e+07. 